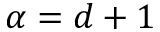<formula> <loc_0><loc_0><loc_500><loc_500>\alpha = d + 1</formula> 